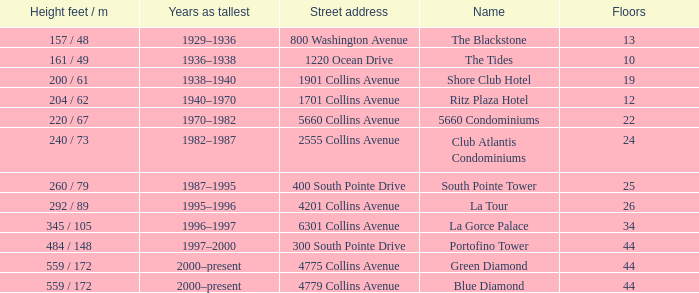How many years was the building with 24 floors the tallest? 1982–1987. 